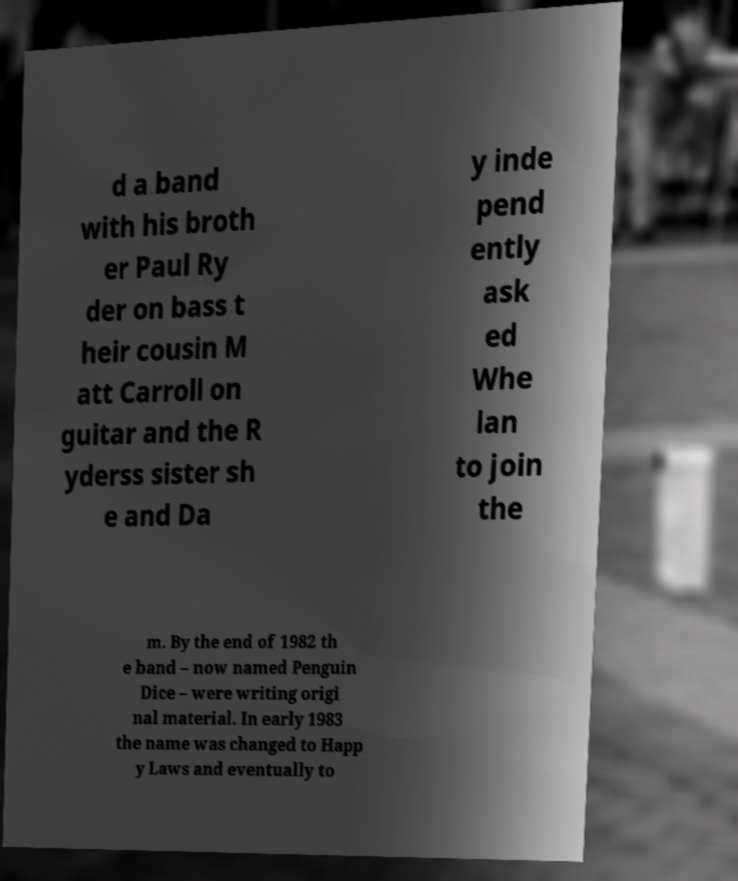For documentation purposes, I need the text within this image transcribed. Could you provide that? d a band with his broth er Paul Ry der on bass t heir cousin M att Carroll on guitar and the R yderss sister sh e and Da y inde pend ently ask ed Whe lan to join the m. By the end of 1982 th e band – now named Penguin Dice – were writing origi nal material. In early 1983 the name was changed to Happ y Laws and eventually to 